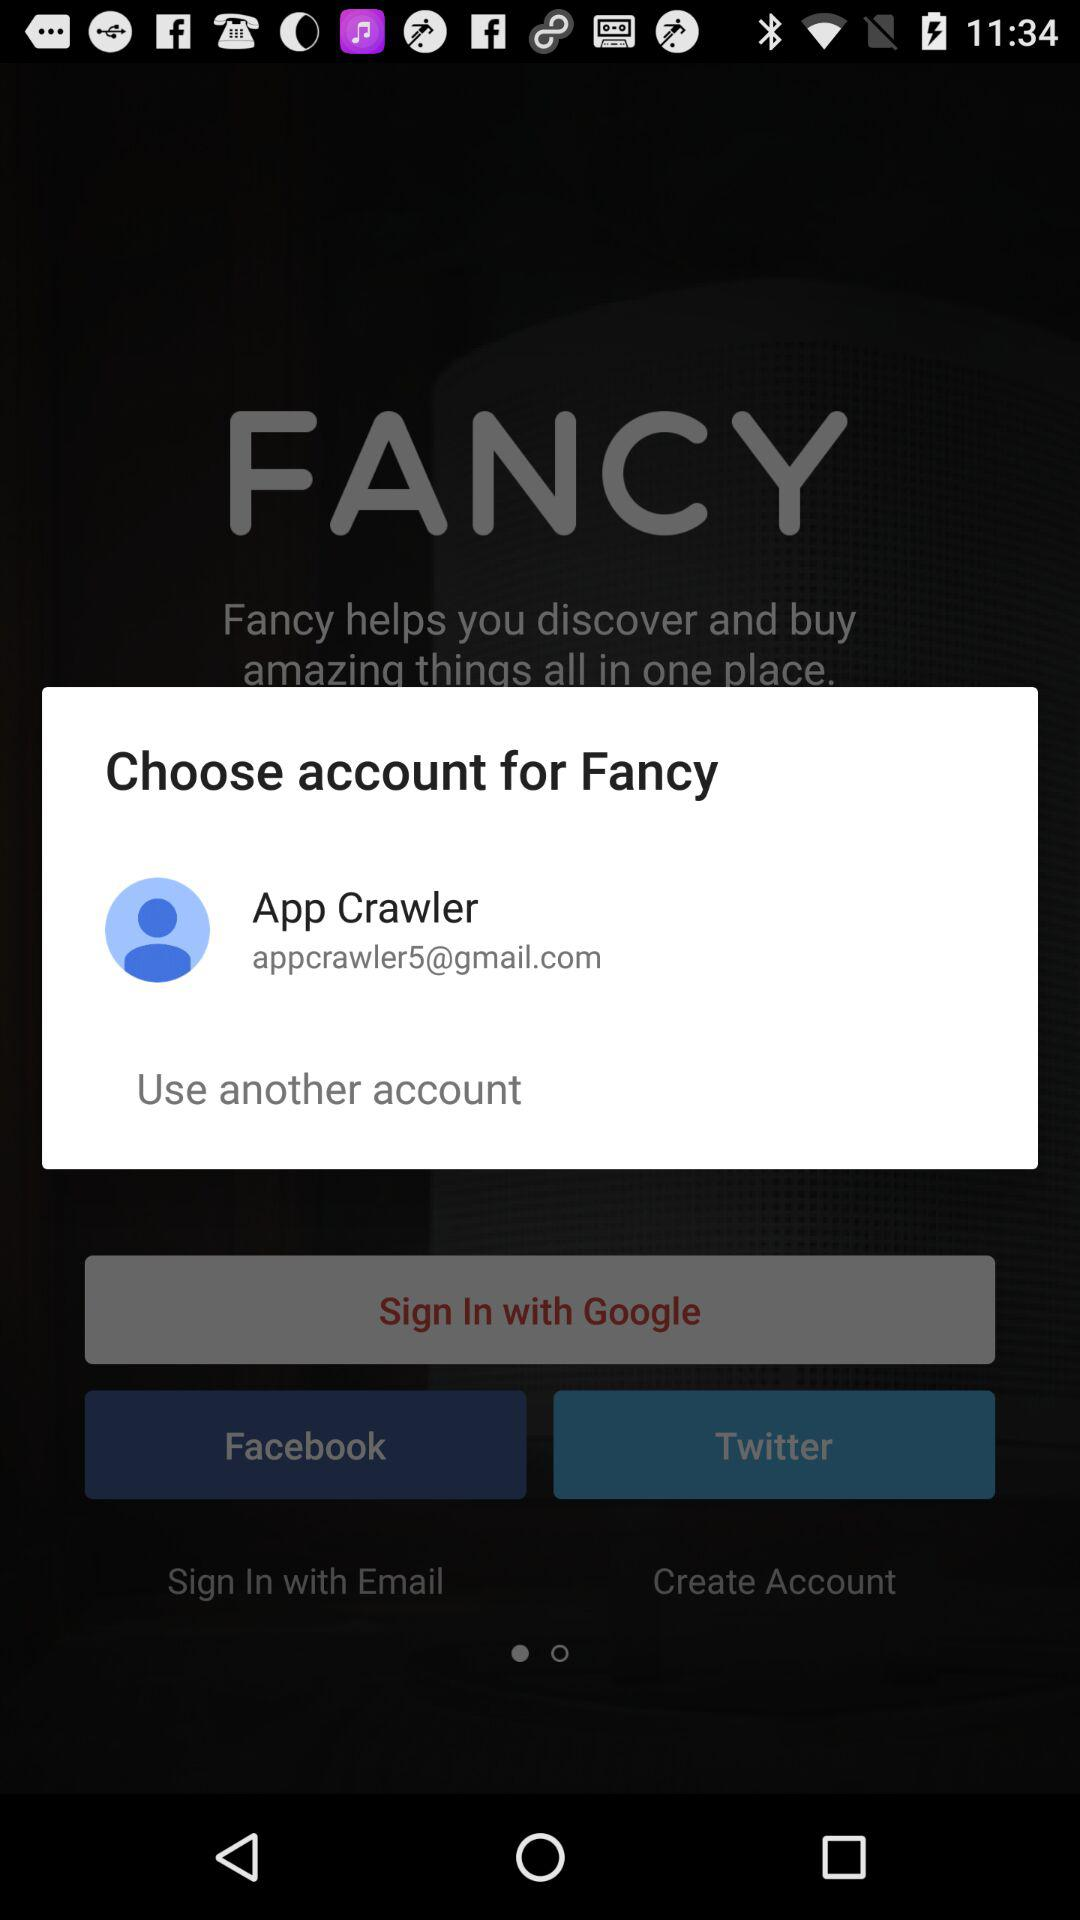What is the name of the user? The name of the user is "App Crawler". 